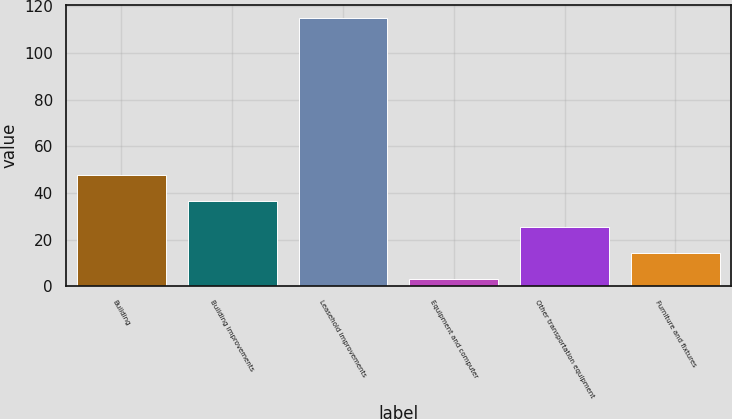<chart> <loc_0><loc_0><loc_500><loc_500><bar_chart><fcel>Building<fcel>Building improvements<fcel>Leasehold improvements<fcel>Equipment and computer<fcel>Other transportation equipment<fcel>Furniture and fixtures<nl><fcel>47.8<fcel>36.6<fcel>115<fcel>3<fcel>25.4<fcel>14.2<nl></chart> 